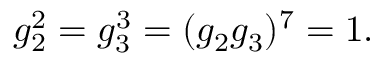<formula> <loc_0><loc_0><loc_500><loc_500>g _ { 2 } ^ { 2 } = g _ { 3 } ^ { 3 } = ( g _ { 2 } g _ { 3 } ) ^ { 7 } = 1 .</formula> 